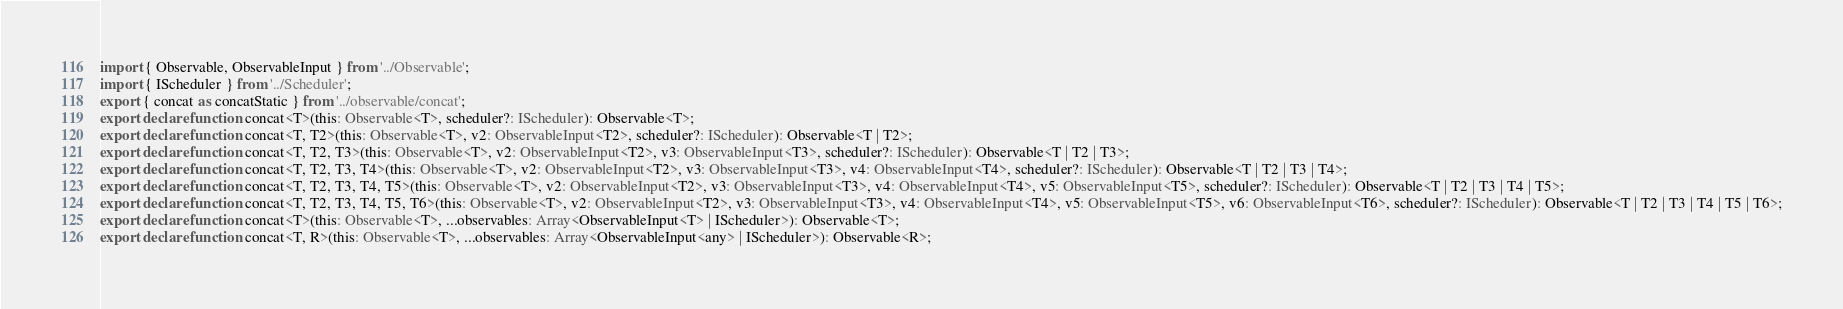<code> <loc_0><loc_0><loc_500><loc_500><_TypeScript_>import { Observable, ObservableInput } from '../Observable';
import { IScheduler } from '../Scheduler';
export { concat as concatStatic } from '../observable/concat';
export declare function concat<T>(this: Observable<T>, scheduler?: IScheduler): Observable<T>;
export declare function concat<T, T2>(this: Observable<T>, v2: ObservableInput<T2>, scheduler?: IScheduler): Observable<T | T2>;
export declare function concat<T, T2, T3>(this: Observable<T>, v2: ObservableInput<T2>, v3: ObservableInput<T3>, scheduler?: IScheduler): Observable<T | T2 | T3>;
export declare function concat<T, T2, T3, T4>(this: Observable<T>, v2: ObservableInput<T2>, v3: ObservableInput<T3>, v4: ObservableInput<T4>, scheduler?: IScheduler): Observable<T | T2 | T3 | T4>;
export declare function concat<T, T2, T3, T4, T5>(this: Observable<T>, v2: ObservableInput<T2>, v3: ObservableInput<T3>, v4: ObservableInput<T4>, v5: ObservableInput<T5>, scheduler?: IScheduler): Observable<T | T2 | T3 | T4 | T5>;
export declare function concat<T, T2, T3, T4, T5, T6>(this: Observable<T>, v2: ObservableInput<T2>, v3: ObservableInput<T3>, v4: ObservableInput<T4>, v5: ObservableInput<T5>, v6: ObservableInput<T6>, scheduler?: IScheduler): Observable<T | T2 | T3 | T4 | T5 | T6>;
export declare function concat<T>(this: Observable<T>, ...observables: Array<ObservableInput<T> | IScheduler>): Observable<T>;
export declare function concat<T, R>(this: Observable<T>, ...observables: Array<ObservableInput<any> | IScheduler>): Observable<R>;
</code> 